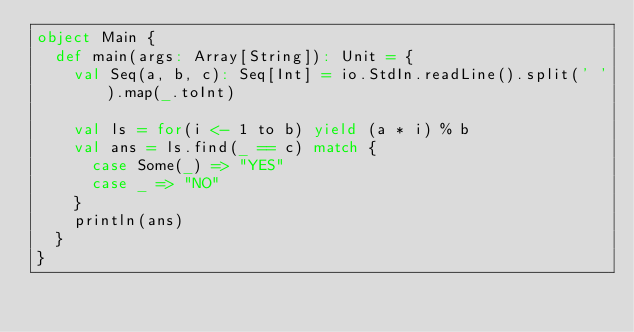<code> <loc_0><loc_0><loc_500><loc_500><_Scala_>object Main {
  def main(args: Array[String]): Unit = {
    val Seq(a, b, c): Seq[Int] = io.StdIn.readLine().split(' ').map(_.toInt)

    val ls = for(i <- 1 to b) yield (a * i) % b
    val ans = ls.find(_ == c) match {
      case Some(_) => "YES"
      case _ => "NO"
    }
    println(ans)
  }
}</code> 